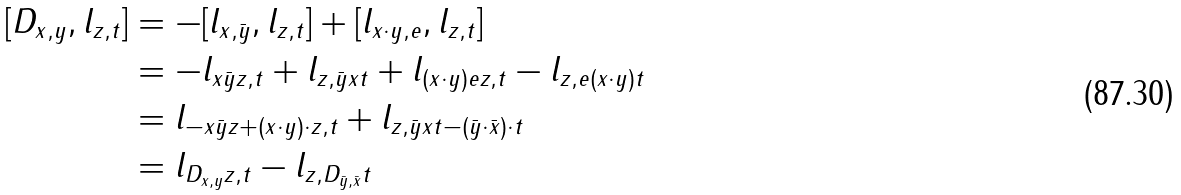Convert formula to latex. <formula><loc_0><loc_0><loc_500><loc_500>[ D _ { x , y } , l _ { z , t } ] & = - [ l _ { x , \bar { y } } , l _ { z , t } ] + [ l _ { x \cdot y , e } , l _ { z , t } ] \\ & = - l _ { x \bar { y } z , t } + l _ { z , \bar { y } x t } + l _ { ( x \cdot y ) e z , t } - l _ { z , e ( x \cdot y ) t } \\ & = l _ { - x \bar { y } z + ( x \cdot y ) \cdot z , t } + l _ { z , \bar { y } x t - ( \bar { y } \cdot \bar { x } ) \cdot t } \\ & = l _ { D _ { x , y } z , t } - l _ { z , D _ { \bar { y } , \bar { x } } t }</formula> 